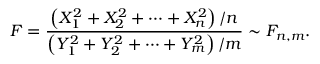<formula> <loc_0><loc_0><loc_500><loc_500>F = { \frac { \left ( X _ { 1 } ^ { 2 } + X _ { 2 } ^ { 2 } + \cdots + X _ { n } ^ { 2 } \right ) / n } { \left ( Y _ { 1 } ^ { 2 } + Y _ { 2 } ^ { 2 } + \cdots + Y _ { m } ^ { 2 } \right ) / m } } \sim F _ { n , m } .</formula> 